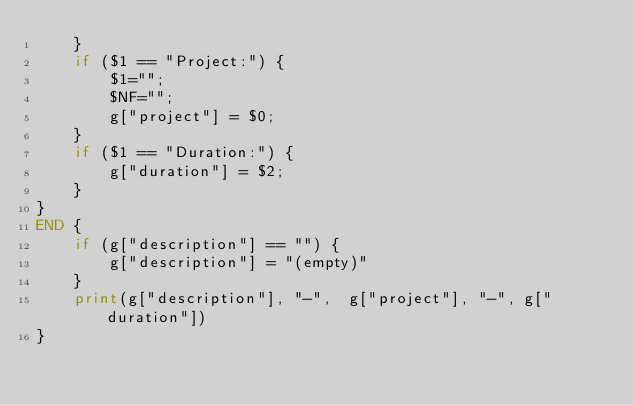Convert code to text. <code><loc_0><loc_0><loc_500><loc_500><_Awk_>    }
    if ($1 == "Project:") {
        $1="";
        $NF="";
        g["project"] = $0;
    }
    if ($1 == "Duration:") {
        g["duration"] = $2;
    }
}
END {
    if (g["description"] == "") {
        g["description"] = "(empty)"
    }
    print(g["description"], "-",  g["project"], "-", g["duration"])
}
</code> 